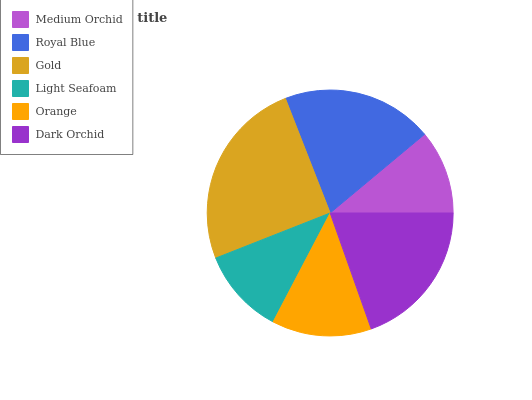Is Medium Orchid the minimum?
Answer yes or no. Yes. Is Gold the maximum?
Answer yes or no. Yes. Is Royal Blue the minimum?
Answer yes or no. No. Is Royal Blue the maximum?
Answer yes or no. No. Is Royal Blue greater than Medium Orchid?
Answer yes or no. Yes. Is Medium Orchid less than Royal Blue?
Answer yes or no. Yes. Is Medium Orchid greater than Royal Blue?
Answer yes or no. No. Is Royal Blue less than Medium Orchid?
Answer yes or no. No. Is Dark Orchid the high median?
Answer yes or no. Yes. Is Orange the low median?
Answer yes or no. Yes. Is Orange the high median?
Answer yes or no. No. Is Dark Orchid the low median?
Answer yes or no. No. 